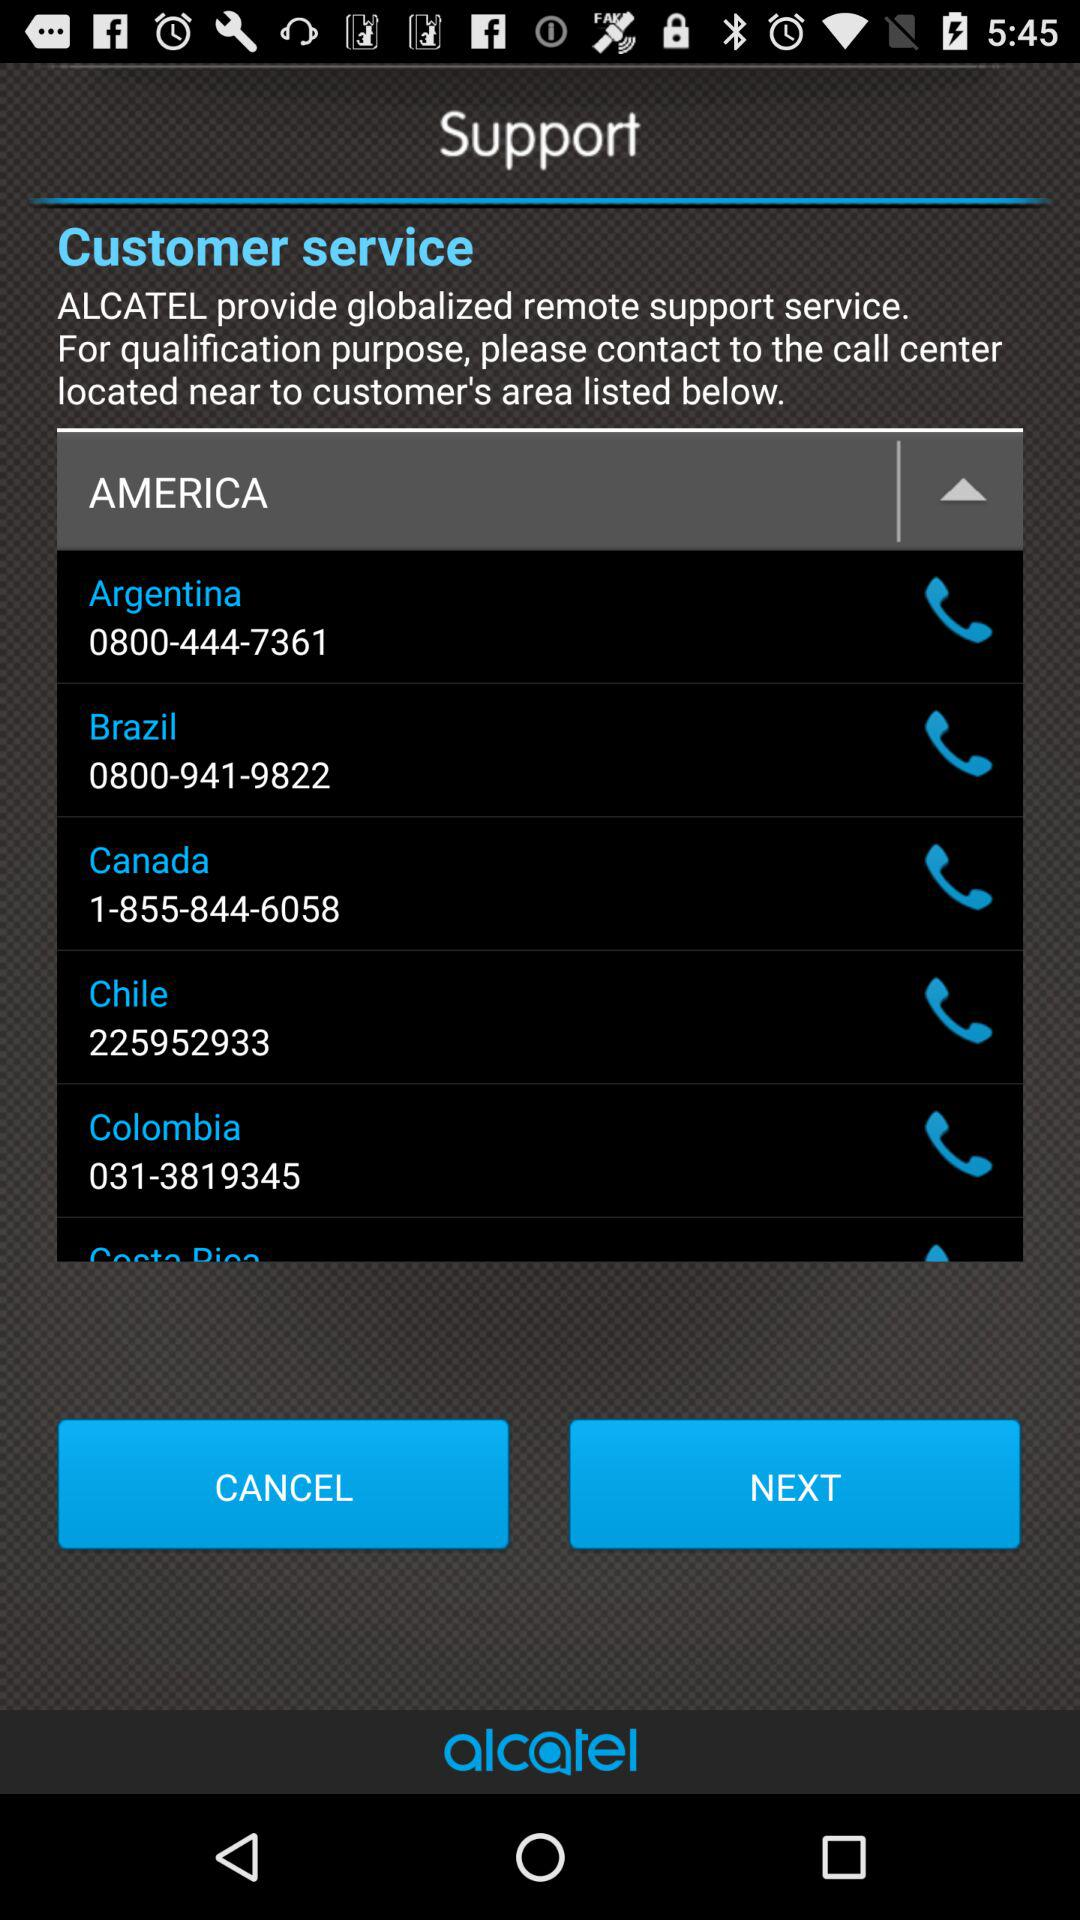What is the name of the application? The name of the application is "alcatel". 